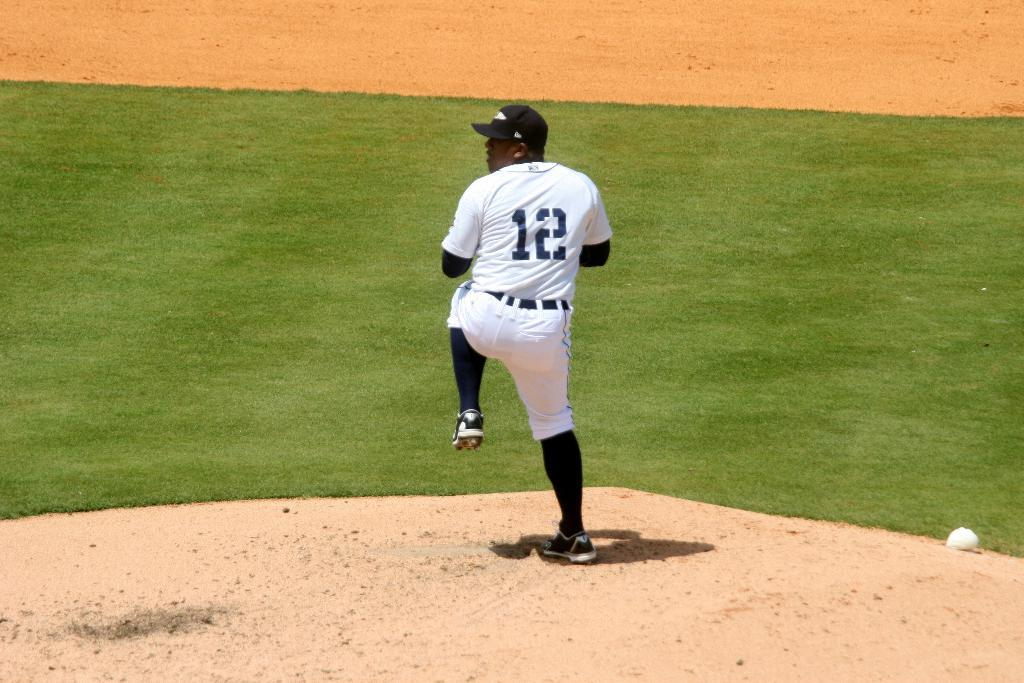Provide a one-sentence caption for the provided image. A baseball player is getting ready to throw a pitch and has a jersey with the number 12 on it. 